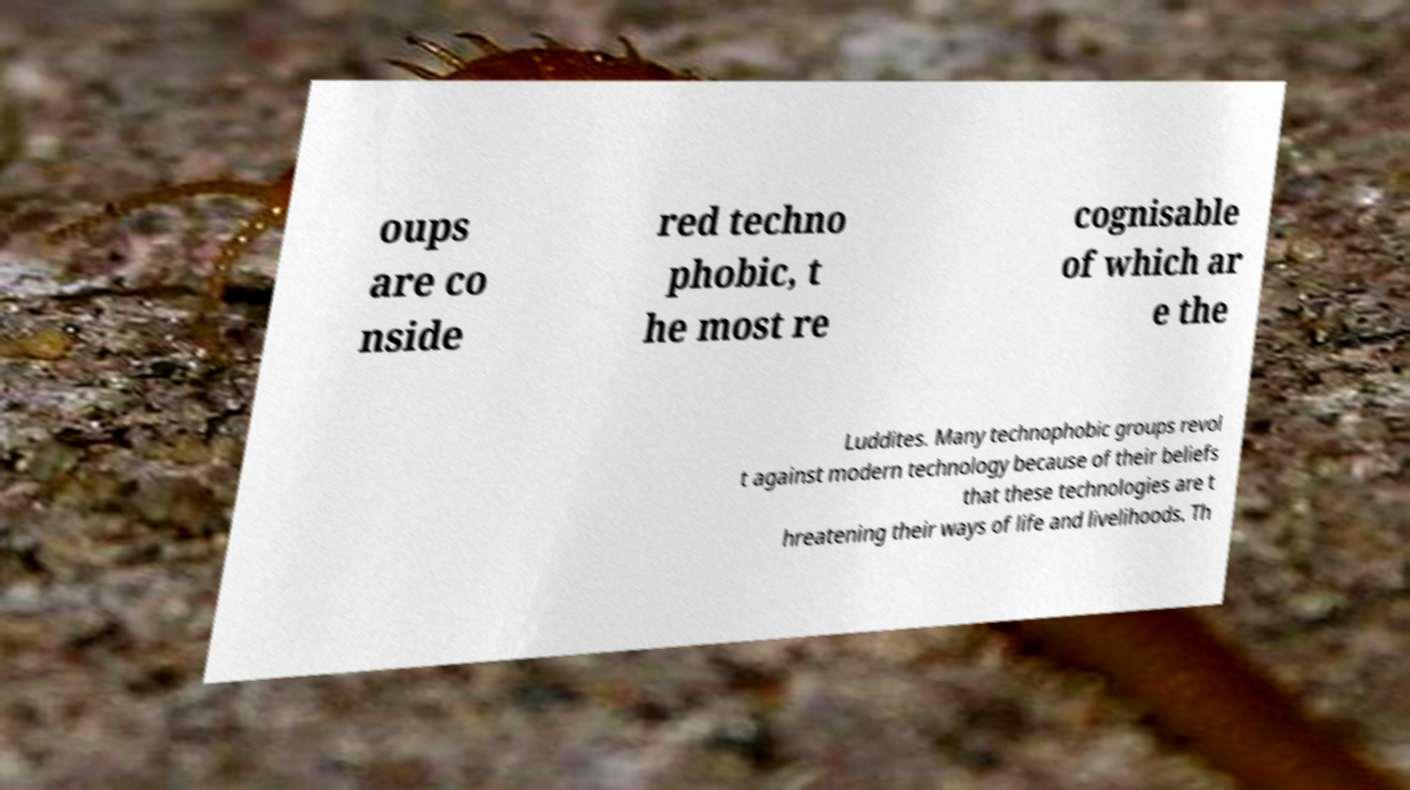Could you assist in decoding the text presented in this image and type it out clearly? oups are co nside red techno phobic, t he most re cognisable of which ar e the Luddites. Many technophobic groups revol t against modern technology because of their beliefs that these technologies are t hreatening their ways of life and livelihoods. Th 